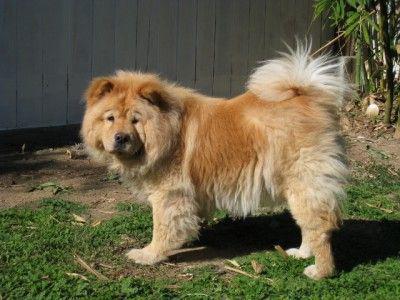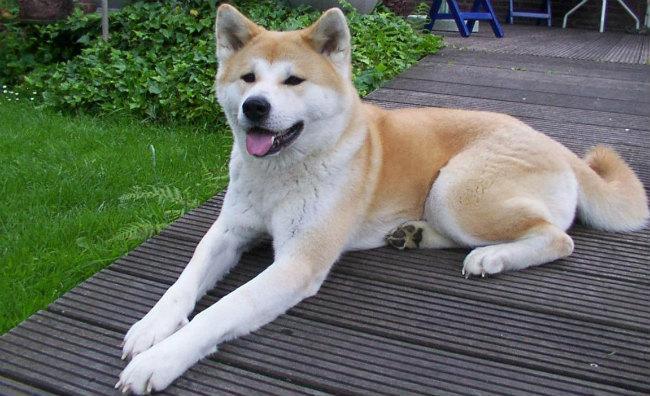The first image is the image on the left, the second image is the image on the right. Examine the images to the left and right. Is the description "Right image features one dog, which is reclining with front paws forward." accurate? Answer yes or no. Yes. The first image is the image on the left, the second image is the image on the right. Examine the images to the left and right. Is the description "The dog in the image on the left is standing." accurate? Answer yes or no. Yes. 